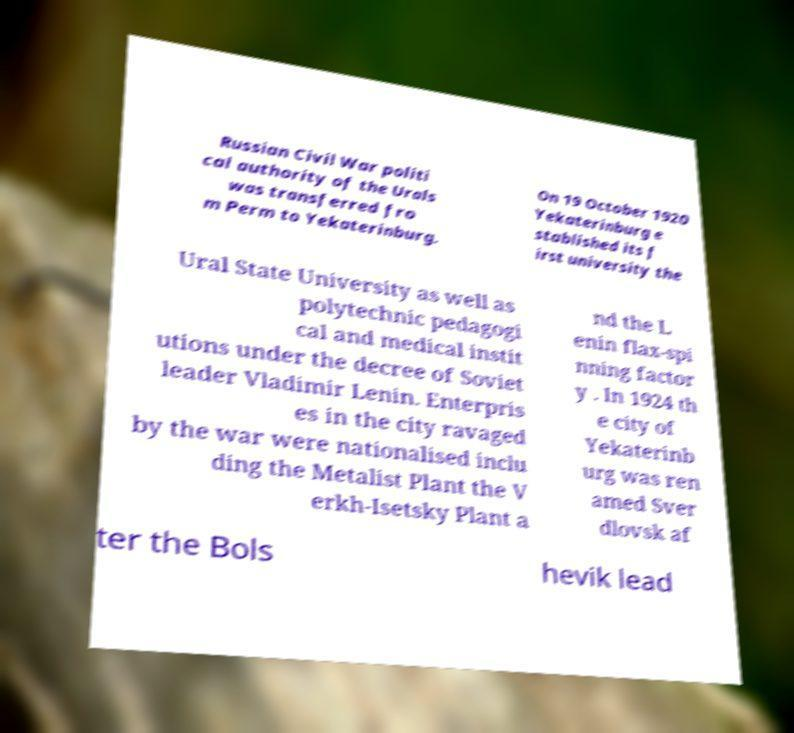Can you read and provide the text displayed in the image?This photo seems to have some interesting text. Can you extract and type it out for me? Russian Civil War politi cal authority of the Urals was transferred fro m Perm to Yekaterinburg. On 19 October 1920 Yekaterinburg e stablished its f irst university the Ural State University as well as polytechnic pedagogi cal and medical instit utions under the decree of Soviet leader Vladimir Lenin. Enterpris es in the city ravaged by the war were nationalised inclu ding the Metalist Plant the V erkh-Isetsky Plant a nd the L enin flax-spi nning factor y . In 1924 th e city of Yekaterinb urg was ren amed Sver dlovsk af ter the Bols hevik lead 